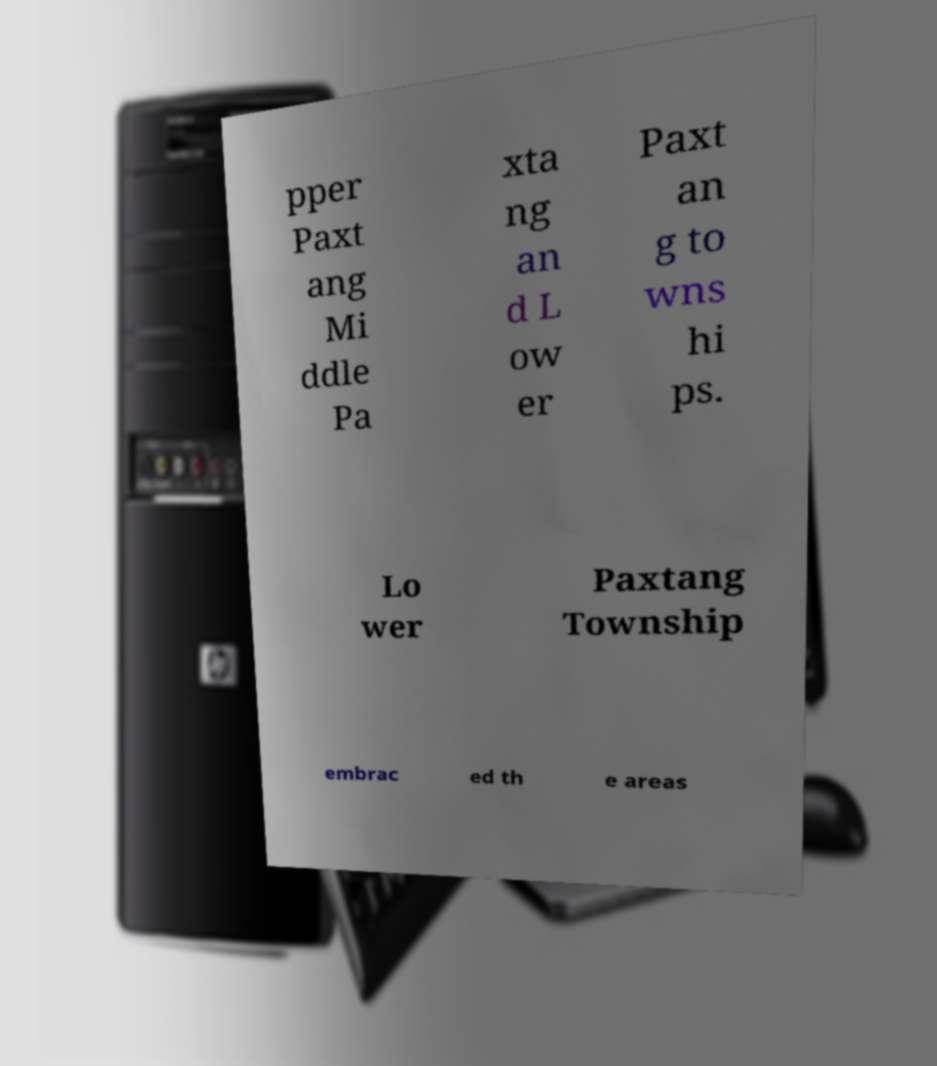For documentation purposes, I need the text within this image transcribed. Could you provide that? pper Paxt ang Mi ddle Pa xta ng an d L ow er Paxt an g to wns hi ps. Lo wer Paxtang Township embrac ed th e areas 